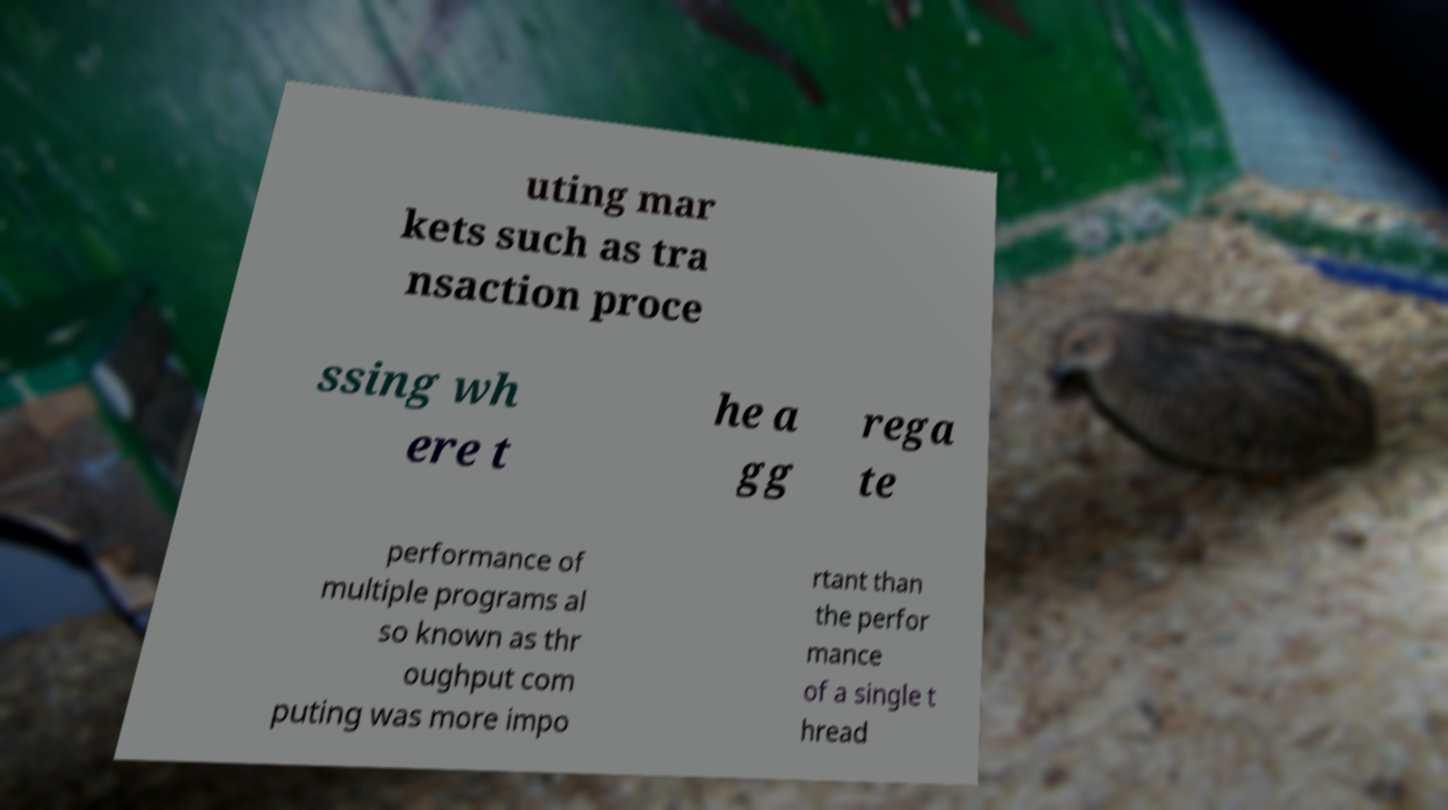I need the written content from this picture converted into text. Can you do that? uting mar kets such as tra nsaction proce ssing wh ere t he a gg rega te performance of multiple programs al so known as thr oughput com puting was more impo rtant than the perfor mance of a single t hread 